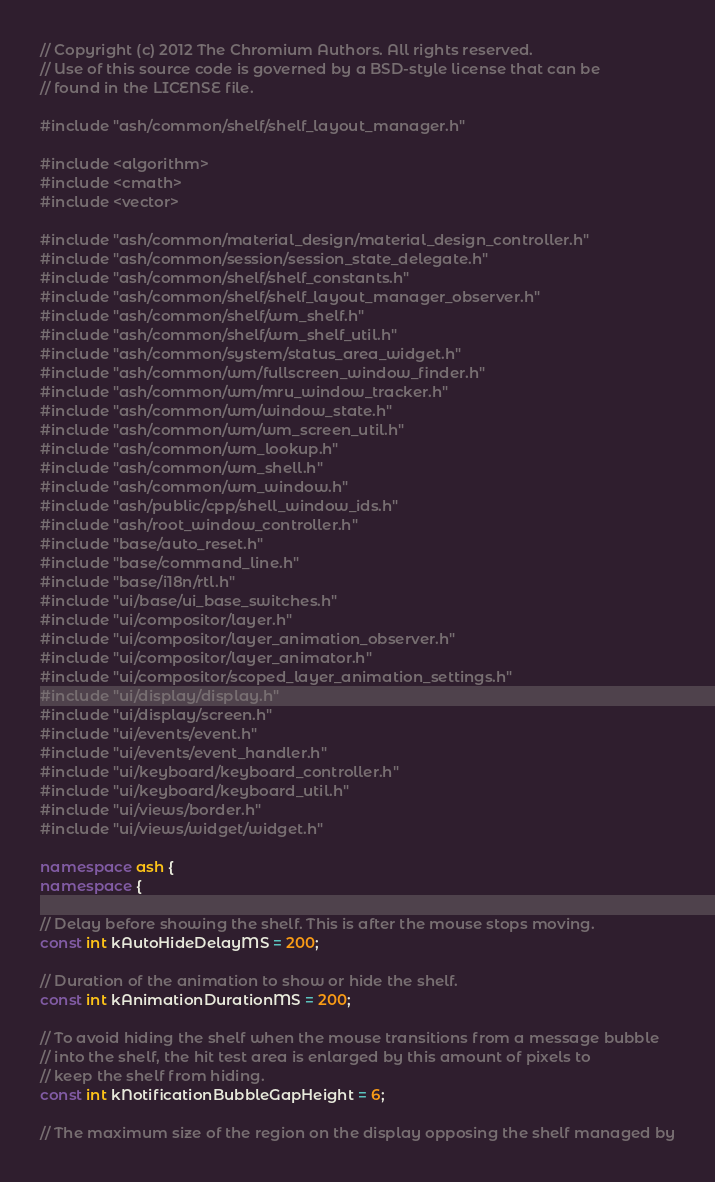Convert code to text. <code><loc_0><loc_0><loc_500><loc_500><_C++_>// Copyright (c) 2012 The Chromium Authors. All rights reserved.
// Use of this source code is governed by a BSD-style license that can be
// found in the LICENSE file.

#include "ash/common/shelf/shelf_layout_manager.h"

#include <algorithm>
#include <cmath>
#include <vector>

#include "ash/common/material_design/material_design_controller.h"
#include "ash/common/session/session_state_delegate.h"
#include "ash/common/shelf/shelf_constants.h"
#include "ash/common/shelf/shelf_layout_manager_observer.h"
#include "ash/common/shelf/wm_shelf.h"
#include "ash/common/shelf/wm_shelf_util.h"
#include "ash/common/system/status_area_widget.h"
#include "ash/common/wm/fullscreen_window_finder.h"
#include "ash/common/wm/mru_window_tracker.h"
#include "ash/common/wm/window_state.h"
#include "ash/common/wm/wm_screen_util.h"
#include "ash/common/wm_lookup.h"
#include "ash/common/wm_shell.h"
#include "ash/common/wm_window.h"
#include "ash/public/cpp/shell_window_ids.h"
#include "ash/root_window_controller.h"
#include "base/auto_reset.h"
#include "base/command_line.h"
#include "base/i18n/rtl.h"
#include "ui/base/ui_base_switches.h"
#include "ui/compositor/layer.h"
#include "ui/compositor/layer_animation_observer.h"
#include "ui/compositor/layer_animator.h"
#include "ui/compositor/scoped_layer_animation_settings.h"
#include "ui/display/display.h"
#include "ui/display/screen.h"
#include "ui/events/event.h"
#include "ui/events/event_handler.h"
#include "ui/keyboard/keyboard_controller.h"
#include "ui/keyboard/keyboard_util.h"
#include "ui/views/border.h"
#include "ui/views/widget/widget.h"

namespace ash {
namespace {

// Delay before showing the shelf. This is after the mouse stops moving.
const int kAutoHideDelayMS = 200;

// Duration of the animation to show or hide the shelf.
const int kAnimationDurationMS = 200;

// To avoid hiding the shelf when the mouse transitions from a message bubble
// into the shelf, the hit test area is enlarged by this amount of pixels to
// keep the shelf from hiding.
const int kNotificationBubbleGapHeight = 6;

// The maximum size of the region on the display opposing the shelf managed by</code> 